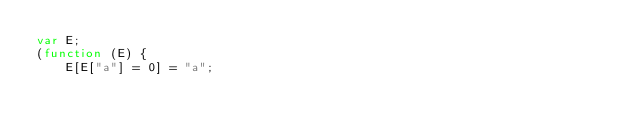<code> <loc_0><loc_0><loc_500><loc_500><_JavaScript_>var E;
(function (E) {
    E[E["a"] = 0] = "a";</code> 